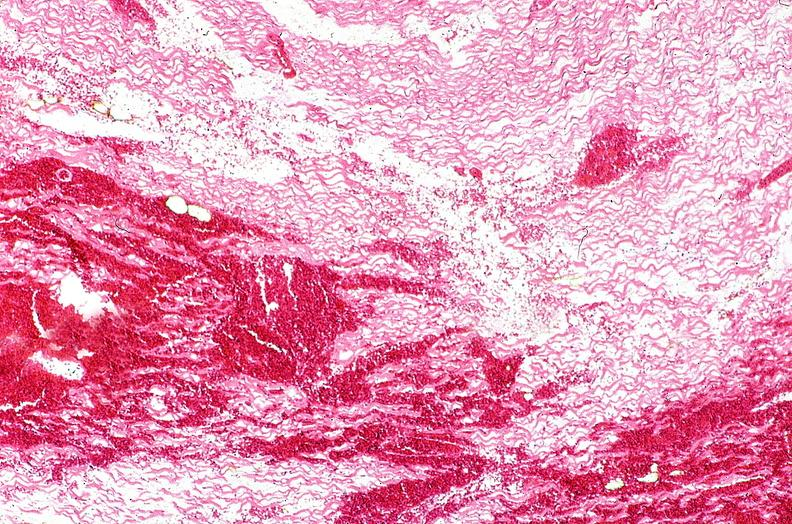where is this from?
Answer the question using a single word or phrase. Heart 